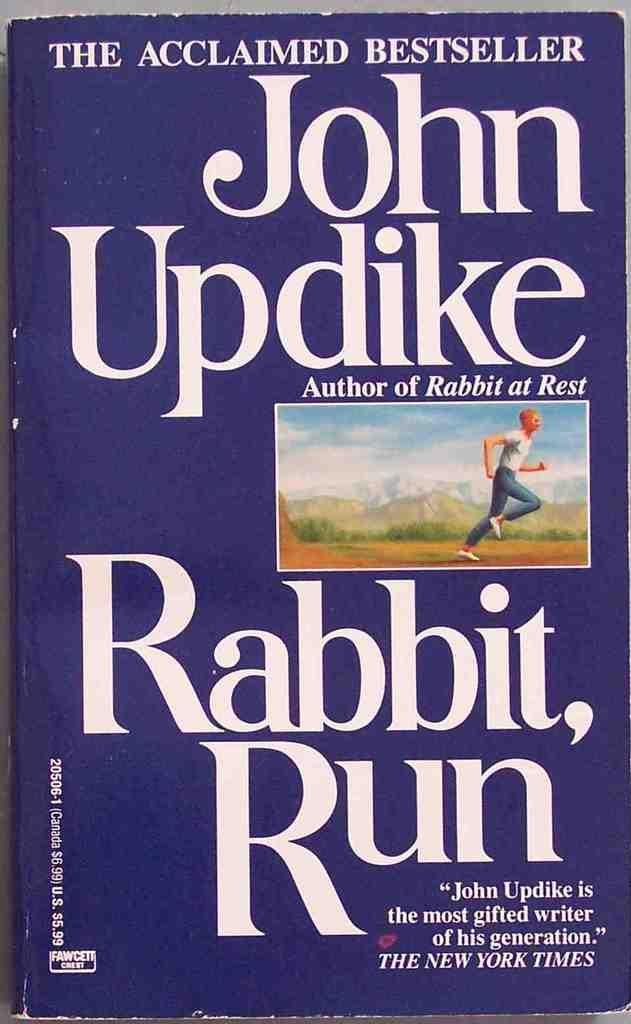<image>
Describe the image concisely. John Updike's Rabbit, Run is an acclaimed bestseller that was reviewed by The New York Times.. 